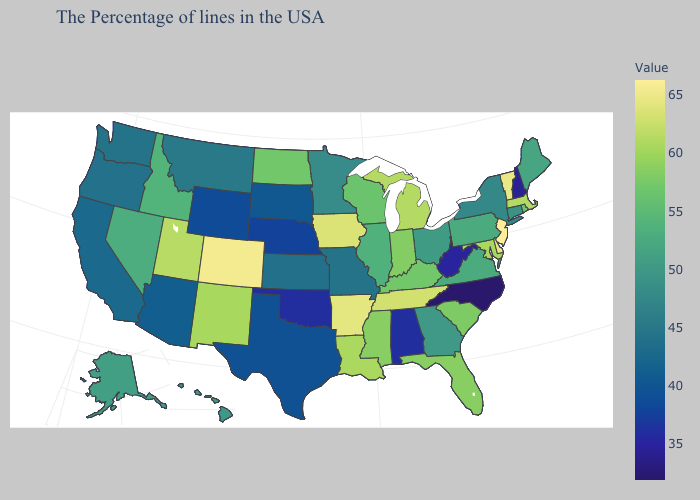Among the states that border Minnesota , which have the highest value?
Quick response, please. Iowa. Among the states that border California , which have the lowest value?
Answer briefly. Arizona. Is the legend a continuous bar?
Short answer required. Yes. Does Kentucky have a lower value than North Carolina?
Concise answer only. No. 